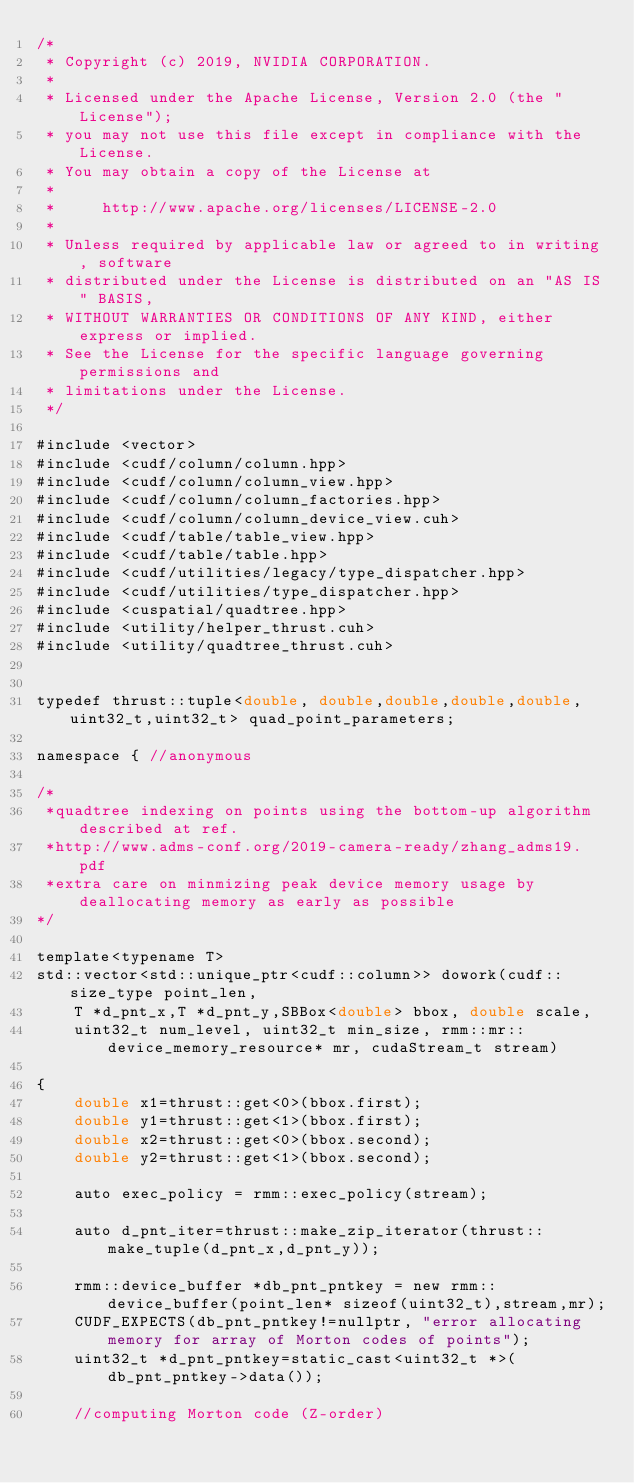<code> <loc_0><loc_0><loc_500><loc_500><_Cuda_>/*
 * Copyright (c) 2019, NVIDIA CORPORATION.
 *
 * Licensed under the Apache License, Version 2.0 (the "License");
 * you may not use this file except in compliance with the License.
 * You may obtain a copy of the License at
 *
 *     http://www.apache.org/licenses/LICENSE-2.0
 *
 * Unless required by applicable law or agreed to in writing, software
 * distributed under the License is distributed on an "AS IS" BASIS,
 * WITHOUT WARRANTIES OR CONDITIONS OF ANY KIND, either express or implied.
 * See the License for the specific language governing permissions and
 * limitations under the License.
 */

#include <vector>
#include <cudf/column/column.hpp>
#include <cudf/column/column_view.hpp>
#include <cudf/column/column_factories.hpp>
#include <cudf/column/column_device_view.cuh>
#include <cudf/table/table_view.hpp>
#include <cudf/table/table.hpp>
#include <cudf/utilities/legacy/type_dispatcher.hpp>
#include <cudf/utilities/type_dispatcher.hpp>
#include <cuspatial/quadtree.hpp>
#include <utility/helper_thrust.cuh>
#include <utility/quadtree_thrust.cuh>


typedef thrust::tuple<double, double,double,double,double,uint32_t,uint32_t> quad_point_parameters;

namespace { //anonymous

/*
 *quadtree indexing on points using the bottom-up algorithm described at ref.
 *http://www.adms-conf.org/2019-camera-ready/zhang_adms19.pdf
 *extra care on minmizing peak device memory usage by deallocating memory as early as possible 
*/

template<typename T>
std::vector<std::unique_ptr<cudf::column>> dowork(cudf::size_type point_len,
    T *d_pnt_x,T *d_pnt_y,SBBox<double> bbox, double scale,
    uint32_t num_level, uint32_t min_size, rmm::mr::device_memory_resource* mr, cudaStream_t stream)
                                         
{
    double x1=thrust::get<0>(bbox.first);
    double y1=thrust::get<1>(bbox.first);
    double x2=thrust::get<0>(bbox.second);
    double y2=thrust::get<1>(bbox.second);
        
    auto exec_policy = rmm::exec_policy(stream);    
     
    auto d_pnt_iter=thrust::make_zip_iterator(thrust::make_tuple(d_pnt_x,d_pnt_y));

    rmm::device_buffer *db_pnt_pntkey = new rmm::device_buffer(point_len* sizeof(uint32_t),stream,mr);
    CUDF_EXPECTS(db_pnt_pntkey!=nullptr, "error allocating memory for array of Morton codes of points");
    uint32_t *d_pnt_pntkey=static_cast<uint32_t *>(db_pnt_pntkey->data());
         
    //computing Morton code (Z-order) </code> 